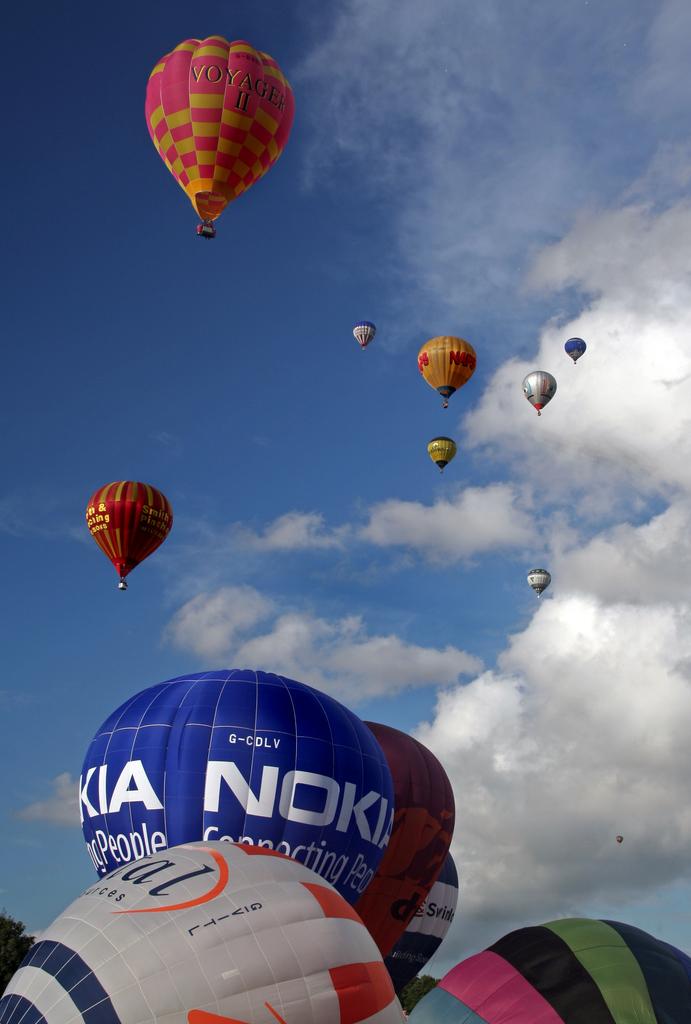Which company is the blue hot air balloon?
Ensure brevity in your answer.  Nokia. What does nokia connect?
Keep it short and to the point. People. 